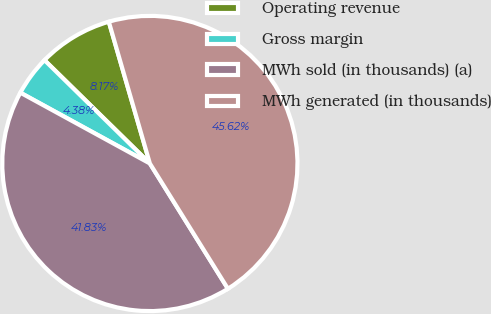<chart> <loc_0><loc_0><loc_500><loc_500><pie_chart><fcel>Operating revenue<fcel>Gross margin<fcel>MWh sold (in thousands) (a)<fcel>MWh generated (in thousands)<nl><fcel>8.17%<fcel>4.38%<fcel>41.83%<fcel>45.62%<nl></chart> 